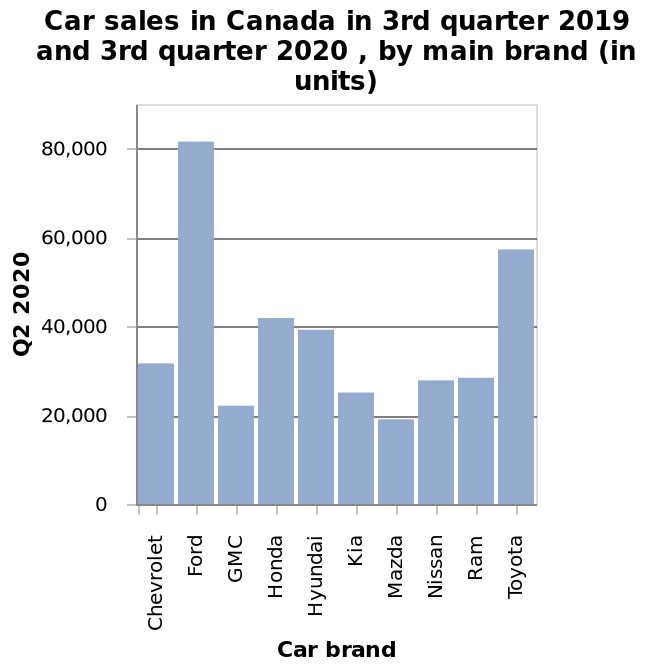<image>
What were the car sales figures for Ford and Toyota in the 3rd quarter of 2019 and 2020? The car sales figures for Ford and Toyota in the 3rd quarter of 2019 and 2020 are not mentioned in the description. What is the range of the y-axis on the bar chart? The range of the y-axis on the bar chart is from 0 to 80,000. What is plotted along the x-axis of the bar chart? The car brand is plotted along the x-axis of the bar chart. 